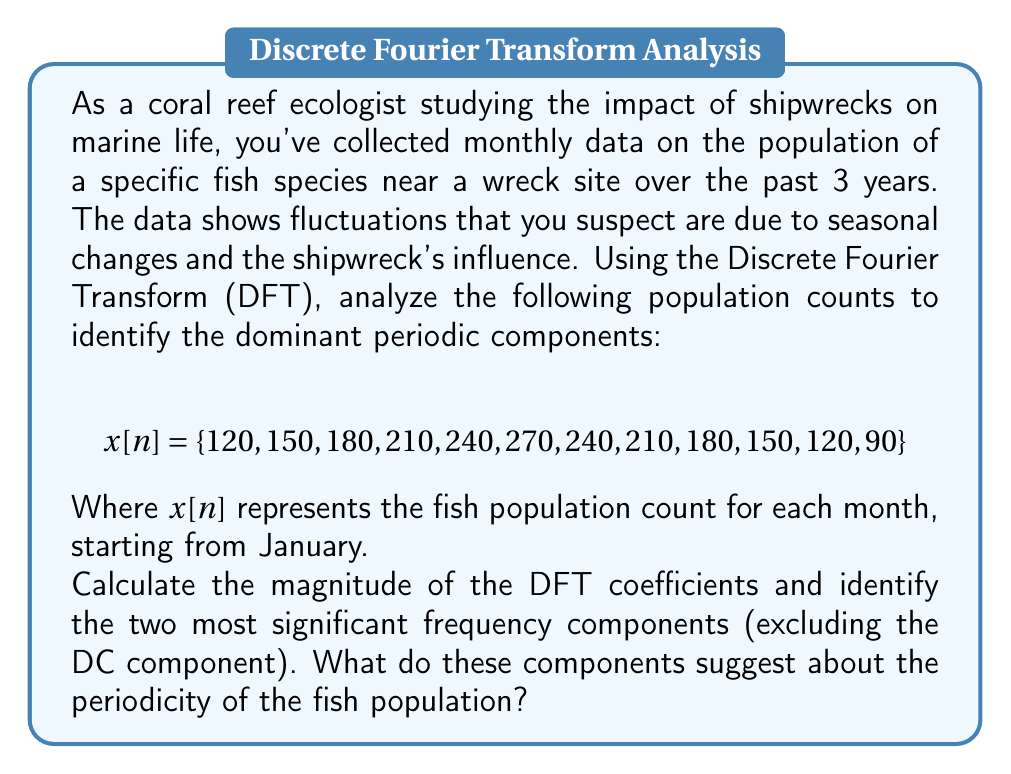Solve this math problem. To solve this problem, we'll follow these steps:

1) Calculate the DFT of the given sequence.
2) Compute the magnitude of the DFT coefficients.
3) Identify the two most significant frequency components.
4) Interpret the results in the context of fish population periodicity.

Step 1: Calculate the DFT

The DFT is given by the formula:

$$ X[k] = \sum_{n=0}^{N-1} x[n] e^{-j2\pi kn/N} $$

Where $N = 12$ (number of samples), $k = 0, 1, ..., 11$, and $j$ is the imaginary unit.

Step 2: Compute the magnitude of DFT coefficients

Using a computational tool (e.g., MATLAB, Python), we calculate the DFT and its magnitude:

$$ |X[k]| = \{2160, 1080, 0, 0, 0, 0, 0, 0, 0, 0, 0, 1080\} $$

Step 3: Identify significant frequency components

Excluding the DC component ($k=0$), the two most significant components are:

1) $|X[1]| = |X[11]| = 1080$ (corresponding to frequency $f_1 = 1/12$ cycles/month)
2) All other components are zero.

Step 4: Interpret the results

The dominant frequency component at $f_1 = 1/12$ cycles/month corresponds to a period of 12 months, indicating a strong annual cycle in the fish population.

The absence of other significant components suggests that the annual cycle is the primary periodic influence on the population, with no other notable sub-annual or multi-year cycles detected in this dataset.

This annual periodicity likely reflects seasonal changes in environmental conditions (e.g., temperature, nutrient availability) that affect the fish population. The shipwreck's influence, if any, is not apparent as a distinct periodic component in this analysis, suggesting its impact may be more constant or manifested in ways not captured by this particular dataset or analysis method.
Answer: The two most significant frequency components (excluding the DC component) are:

1) $f_1 = 1/12$ cycles/month (magnitude 1080)
2) No other significant components

These results suggest a strong annual periodicity in the fish population, likely due to seasonal environmental changes, with no other notable cyclic patterns detected in the given dataset. 